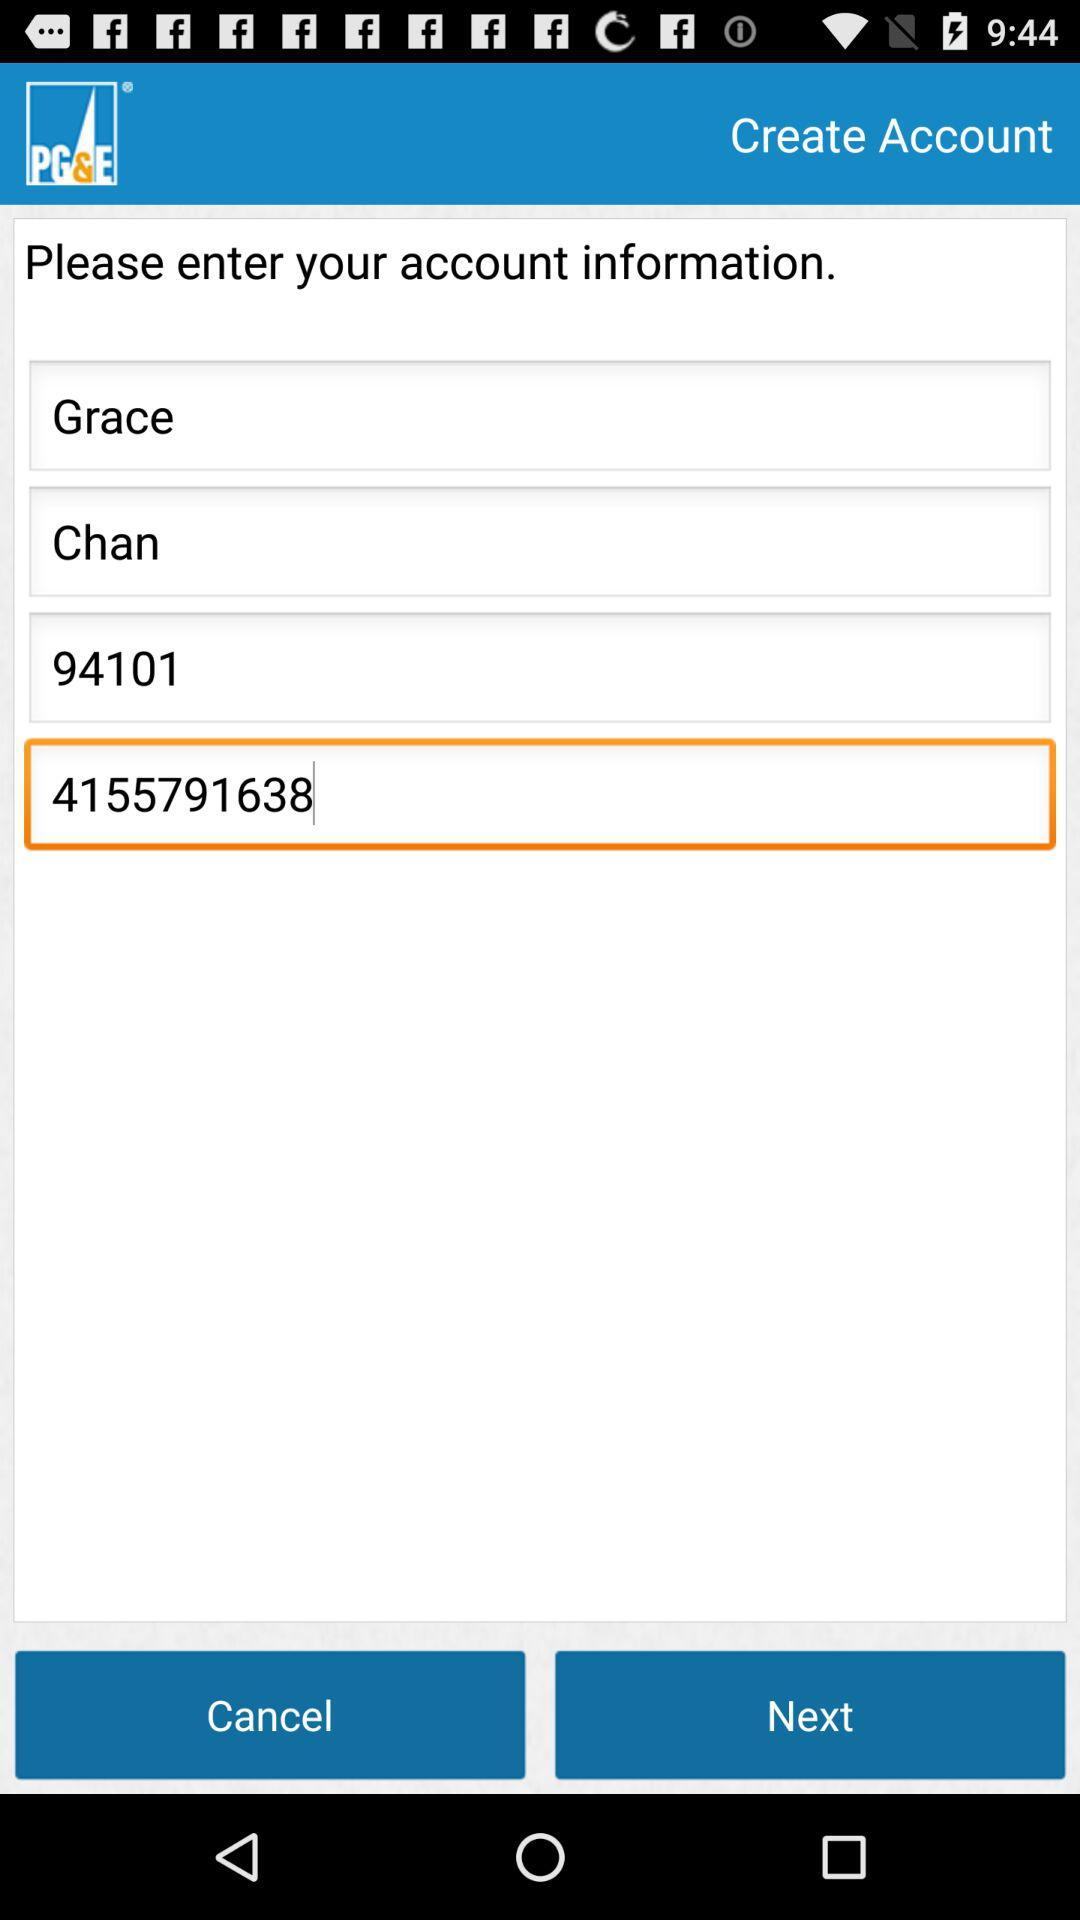What is the user name? The user name is Grace Chan. 